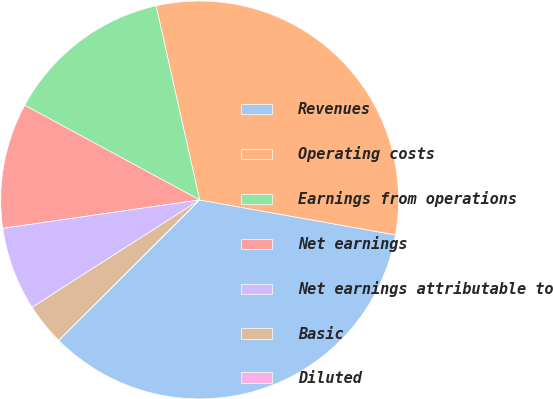<chart> <loc_0><loc_0><loc_500><loc_500><pie_chart><fcel>Revenues<fcel>Operating costs<fcel>Earnings from operations<fcel>Net earnings<fcel>Net earnings attributable to<fcel>Basic<fcel>Diluted<nl><fcel>34.72%<fcel>31.33%<fcel>13.58%<fcel>10.18%<fcel>6.79%<fcel>3.4%<fcel>0.0%<nl></chart> 